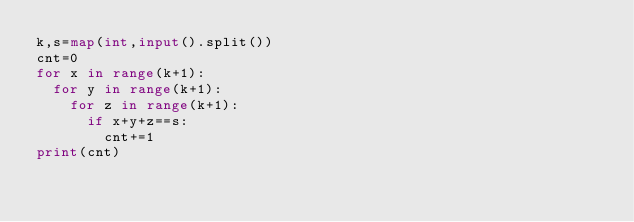<code> <loc_0><loc_0><loc_500><loc_500><_Python_>k,s=map(int,input().split())
cnt=0
for x in range(k+1):
  for y in range(k+1):
    for z in range(k+1):
      if x+y+z==s:
        cnt+=1
print(cnt)</code> 